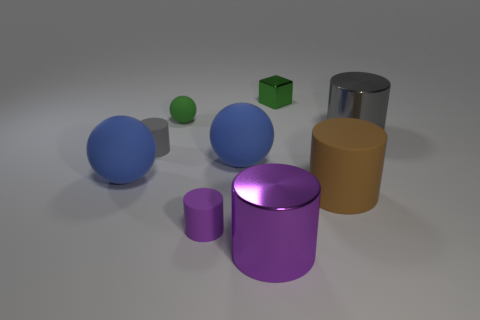What geometric shapes are present in the image? The image features a variety of three-dimensional shapes, including spheres, a cube, and cylinders.  Can you describe the colors of the objects? Certainly! There are two large blue spheres, a green cube, a small green sphere, a large purple cylinder, and a large tan cylinder. 